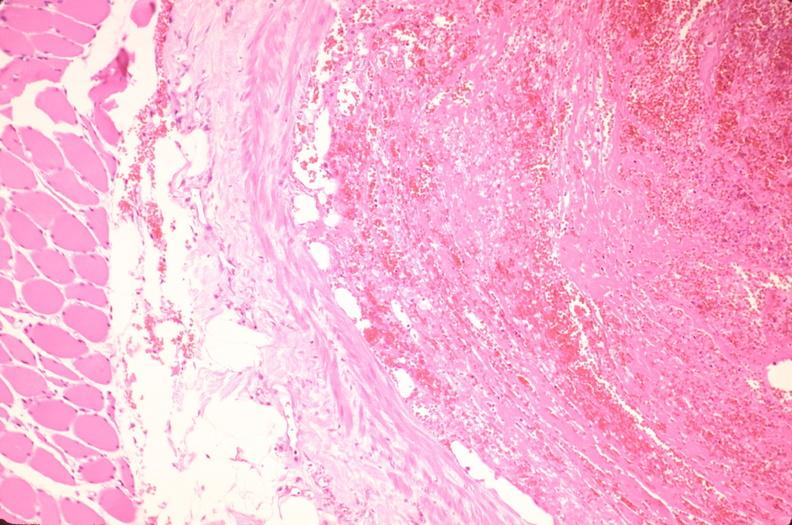s vasculature present?
Answer the question using a single word or phrase. Yes 